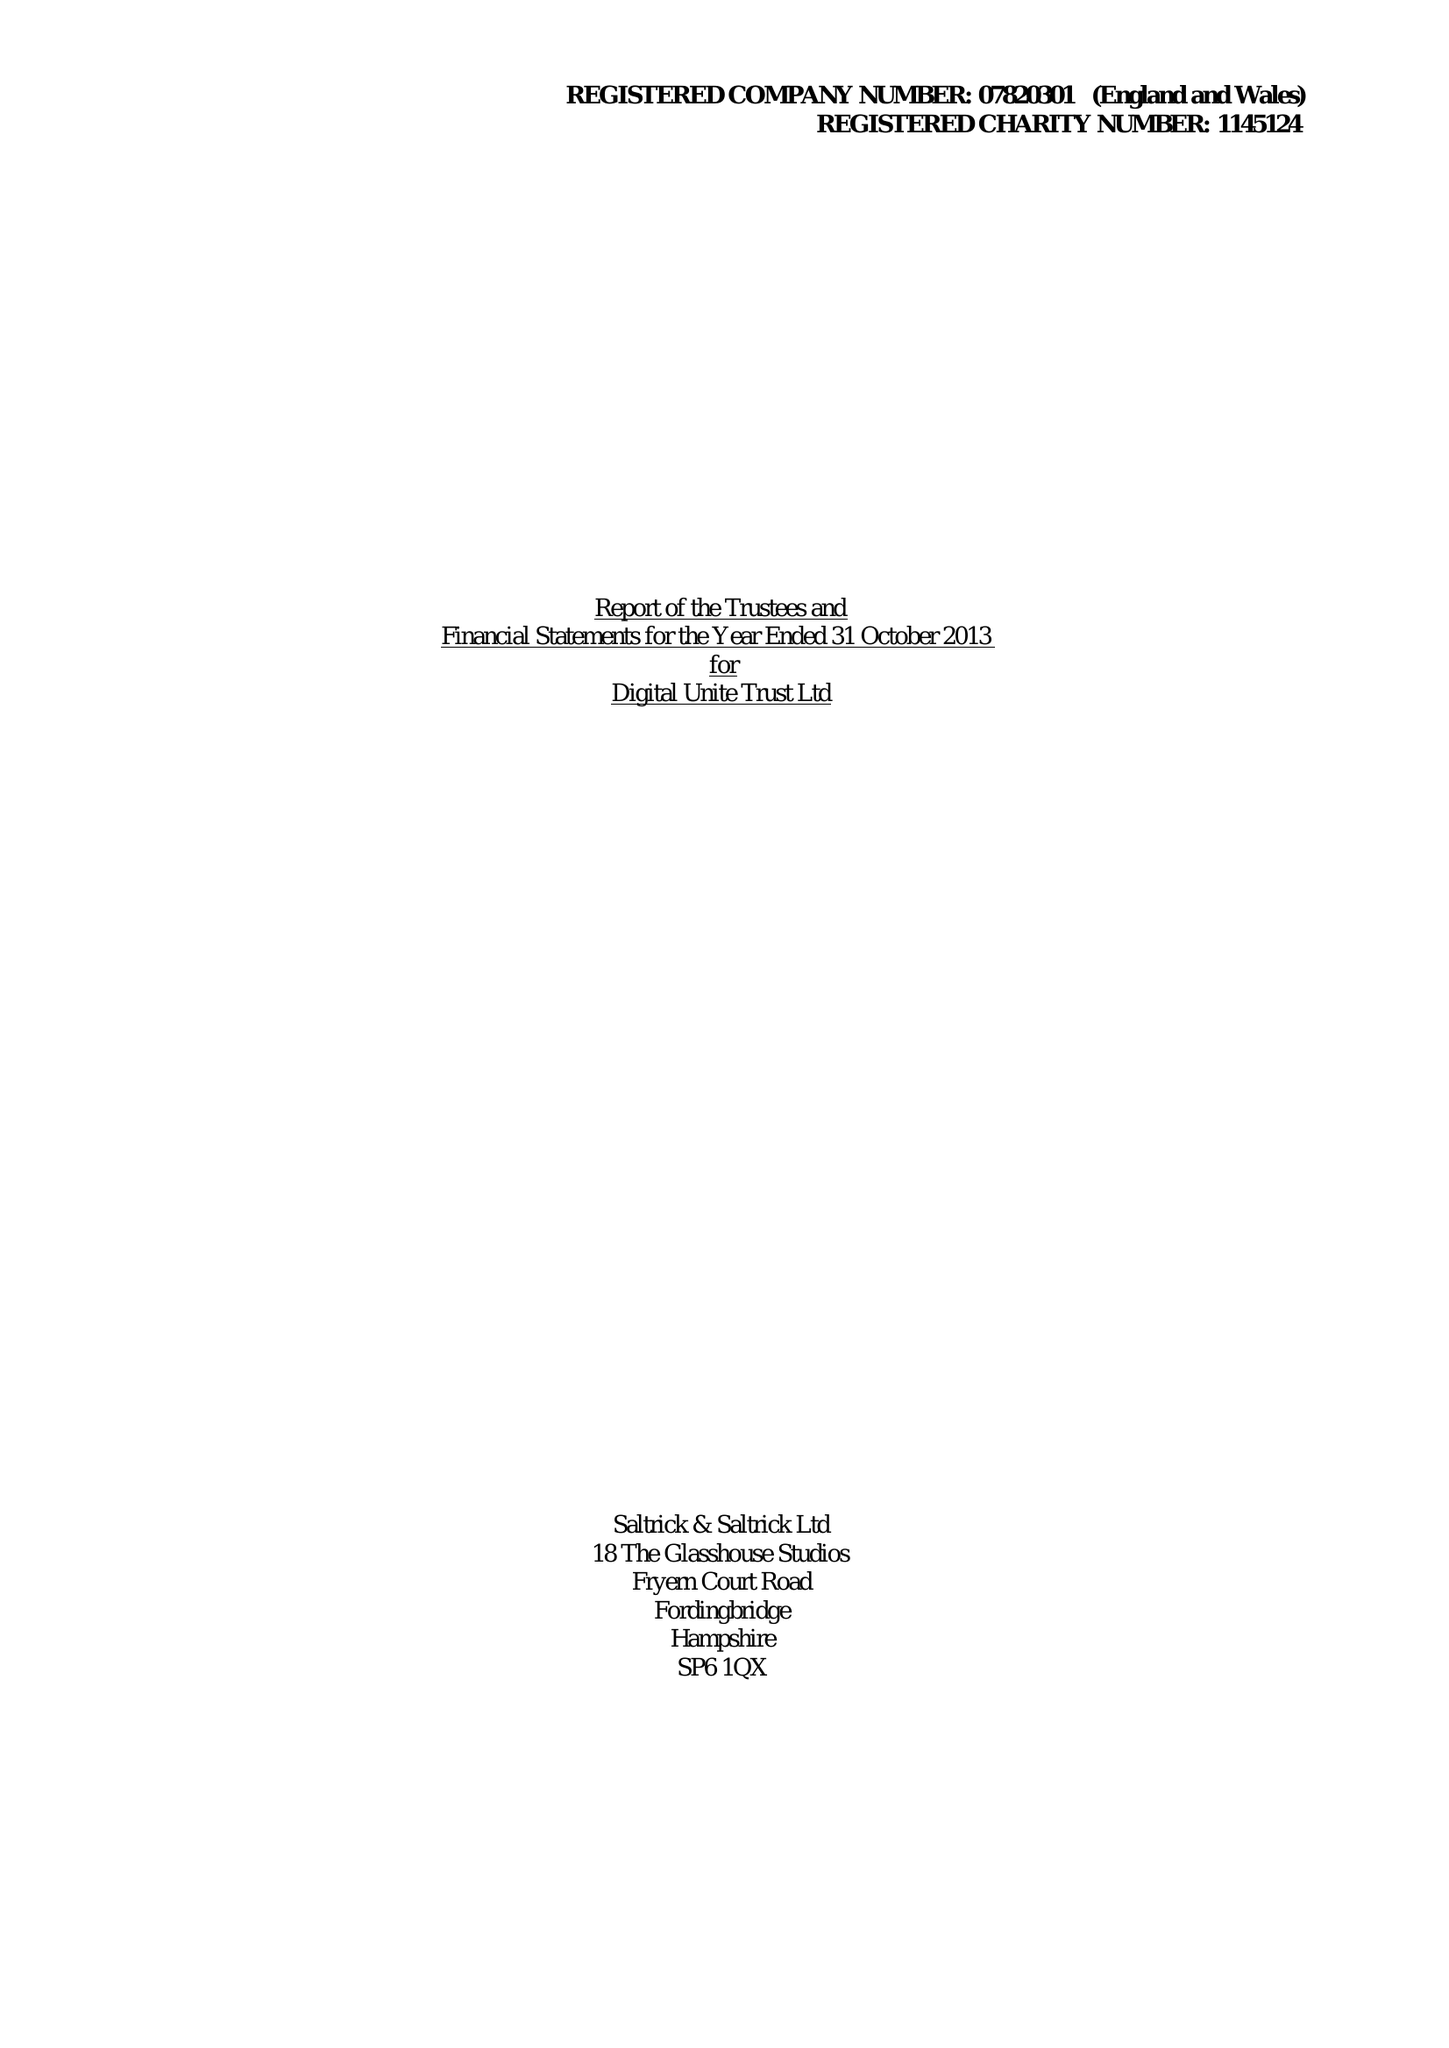What is the value for the charity_number?
Answer the question using a single word or phrase. 1145124 